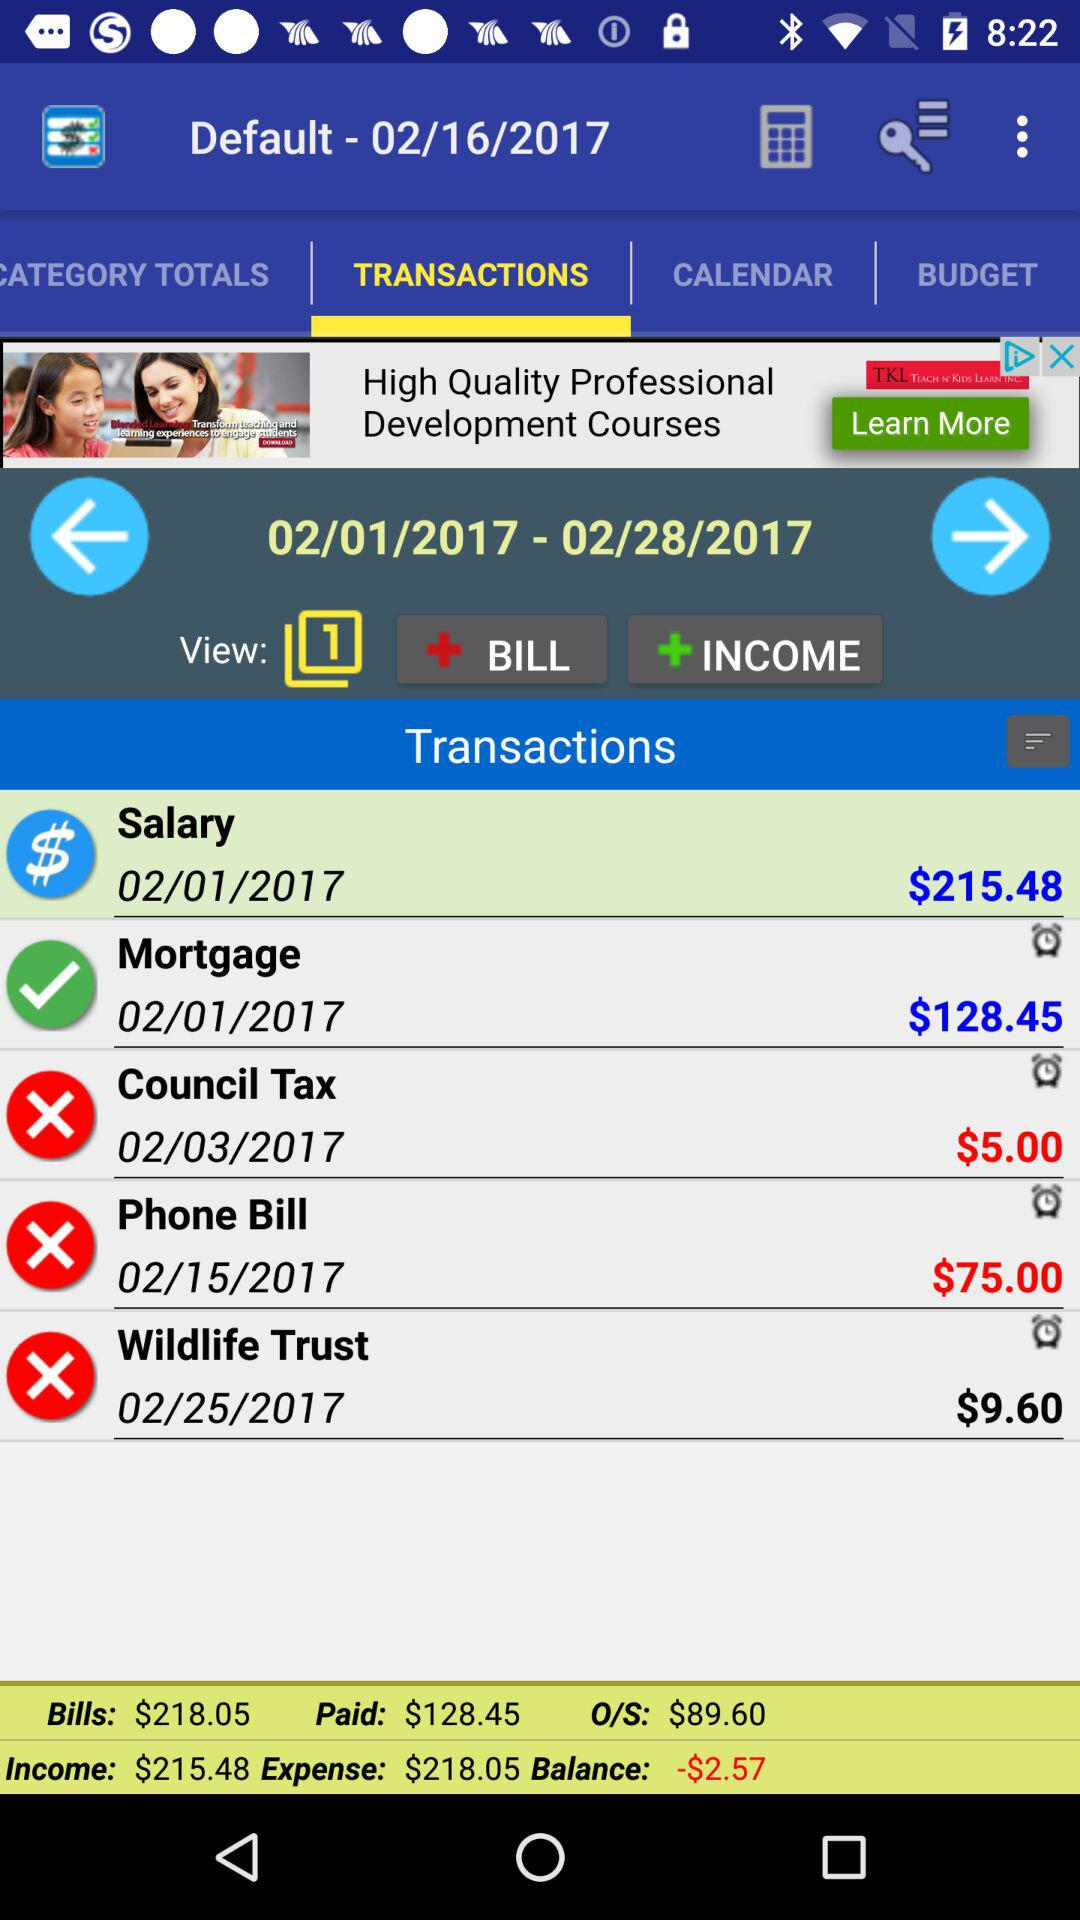What amount is shown on the mortgage bill? The amount shown on the mortgage bill is $128.45. 